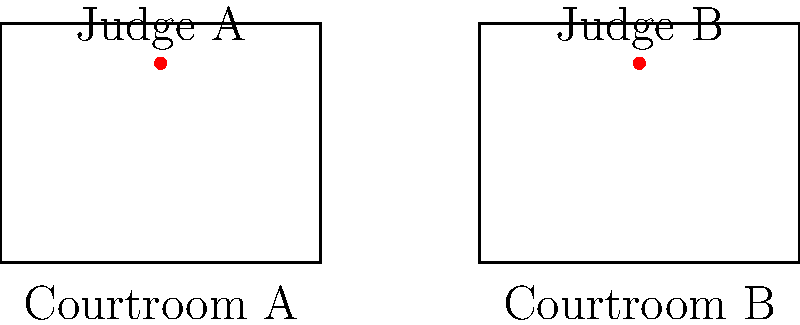In the diagram above, two courtroom layouts are shown with the position of the judge's bench marked in red. Are these two courtroom layouts congruent? If so, describe the transformation that maps one onto the other. To determine if the two courtroom layouts are congruent, we need to follow these steps:

1. Compare the shapes: Both courtrooms are rectangles, which is a good start for potential congruence.

2. Compare the dimensions: 
   - Courtroom A: 4 units wide, 3 units long
   - Courtroom B: 4 units wide, 3 units long
   The dimensions are identical, which is necessary for congruence.

3. Compare the position of the judge's bench:
   - In both courtrooms, the judge's bench is centered horizontally and positioned near the top of the rectangle.
   - The exact position appears to be (2, 2.5) in Courtroom A and (8, 2.5) in Courtroom B, relative to their respective coordinate systems.

4. Identify the transformation:
   - The courtrooms have the same size and shape, and the judge's bench is in the same relative position in both.
   - Courtroom B appears to be a translation of Courtroom A, shifted 6 units to the right.

5. Verify the transformation:
   - If we translate every point of Courtroom A by the vector $(6, 0)$, we get the corresponding points of Courtroom B.
   - This includes the judge's bench: $(2, 2.5) + (6, 0) = (8, 2.5)$

Therefore, the two courtroom layouts are indeed congruent. The transformation that maps Courtroom A onto Courtroom B is a translation 6 units to the right, which can be represented by the vector $(6, 0)$.
Answer: Yes, translation by vector $(6, 0)$ 